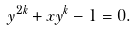<formula> <loc_0><loc_0><loc_500><loc_500>y ^ { 2 k } + x y ^ { k } - 1 = 0 .</formula> 